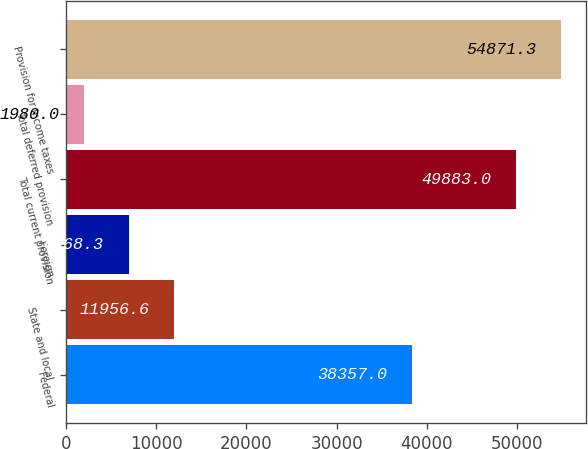Convert chart. <chart><loc_0><loc_0><loc_500><loc_500><bar_chart><fcel>Federal<fcel>State and local<fcel>Foreign<fcel>Total current provision<fcel>Total deferred provision<fcel>Provision for income taxes<nl><fcel>38357<fcel>11956.6<fcel>6968.3<fcel>49883<fcel>1980<fcel>54871.3<nl></chart> 